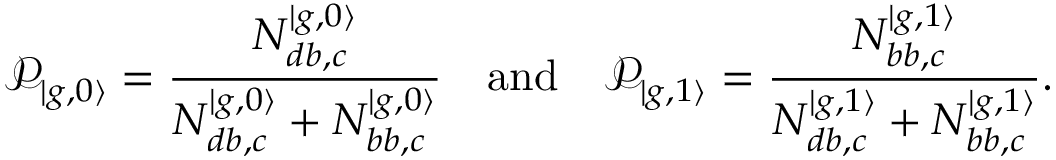<formula> <loc_0><loc_0><loc_500><loc_500>\mathcal { P } _ { | { g , 0 \rangle } } = \frac { N _ { d b , c } ^ { | g , 0 \rangle } } { N _ { d b , c } ^ { | g , 0 \rangle } + N _ { b b , c } ^ { | g , 0 \rangle } } \quad a n d \quad \mathcal { P } _ { | { g , 1 \rangle } } = \frac { N _ { b b , c } ^ { | g , 1 \rangle } } { N _ { d b , c } ^ { | g , 1 \rangle } + N _ { b b , c } ^ { | g , 1 \rangle } } .</formula> 